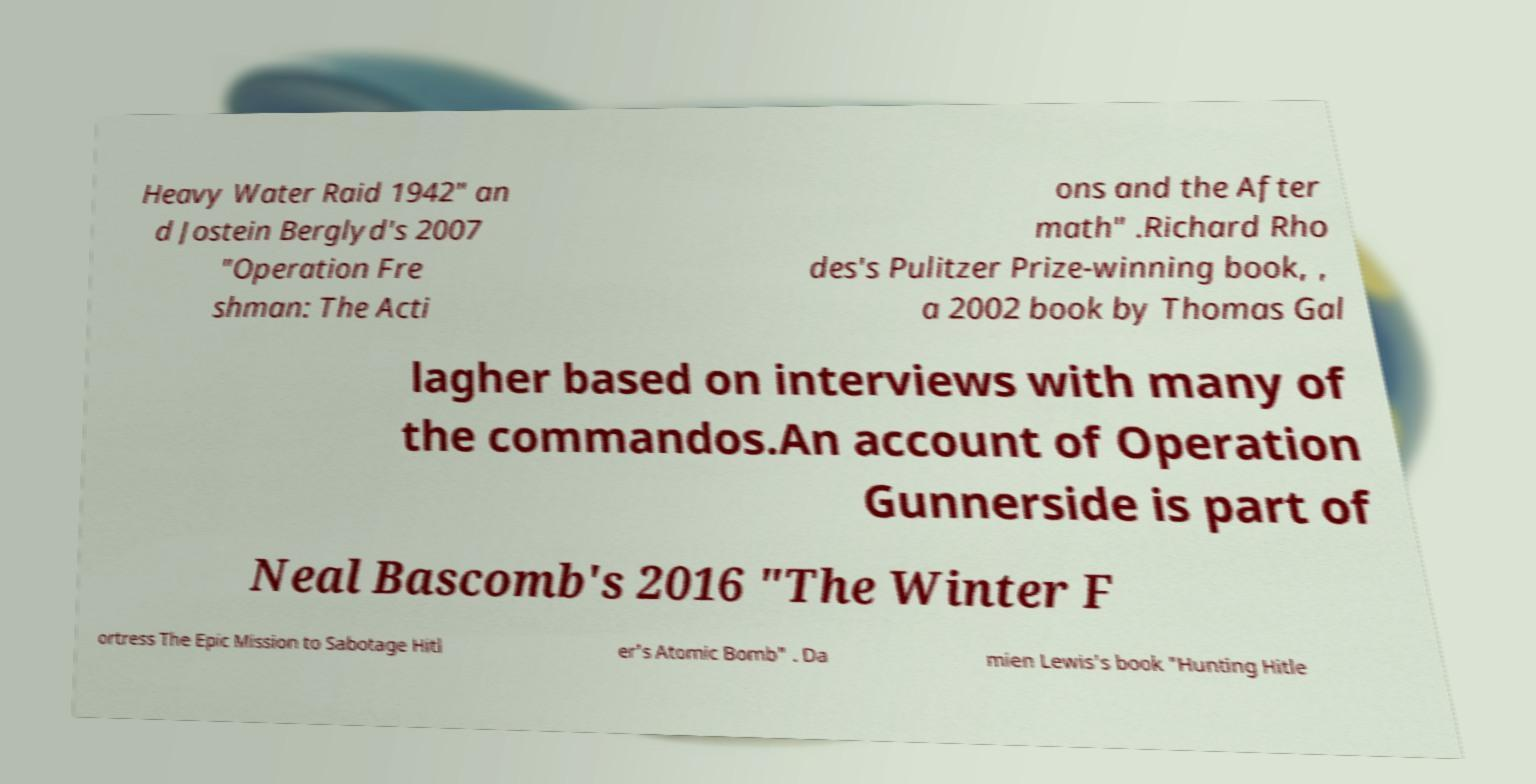Can you accurately transcribe the text from the provided image for me? Heavy Water Raid 1942" an d Jostein Berglyd's 2007 "Operation Fre shman: The Acti ons and the After math" .Richard Rho des's Pulitzer Prize-winning book, , a 2002 book by Thomas Gal lagher based on interviews with many of the commandos.An account of Operation Gunnerside is part of Neal Bascomb's 2016 "The Winter F ortress The Epic Mission to Sabotage Hitl er's Atomic Bomb" . Da mien Lewis's book "Hunting Hitle 